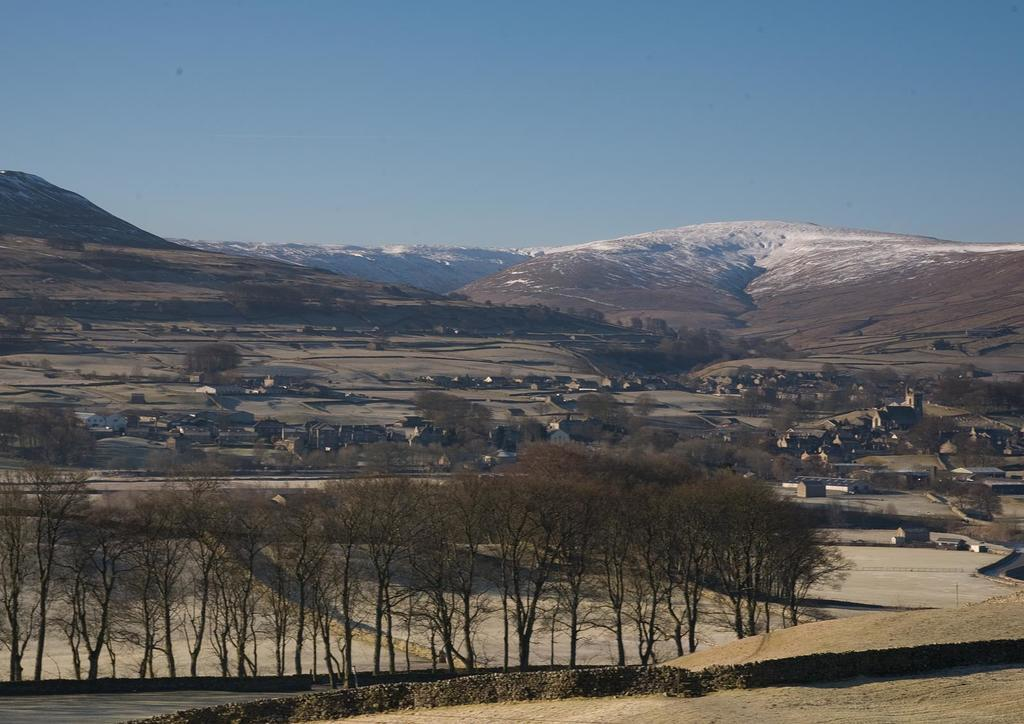What type of natural elements can be seen in the image? There are trees in the image. What type of man-made structures are present in the image? There are buildings in the image. What is visible beneath the trees and buildings? The ground is visible in the image. What type of geographical feature can be seen in the background of the image? There are mountains in the background of the image. What is the color of the area near the mountains? The area near the mountains appears to be white. What is visible above the trees and buildings? The blue sky is visible in the image. Can you see a nest in the trees in the image? There is no nest visible in the trees in the image. Is there a doctor present in the image? There is no doctor present in the image. 